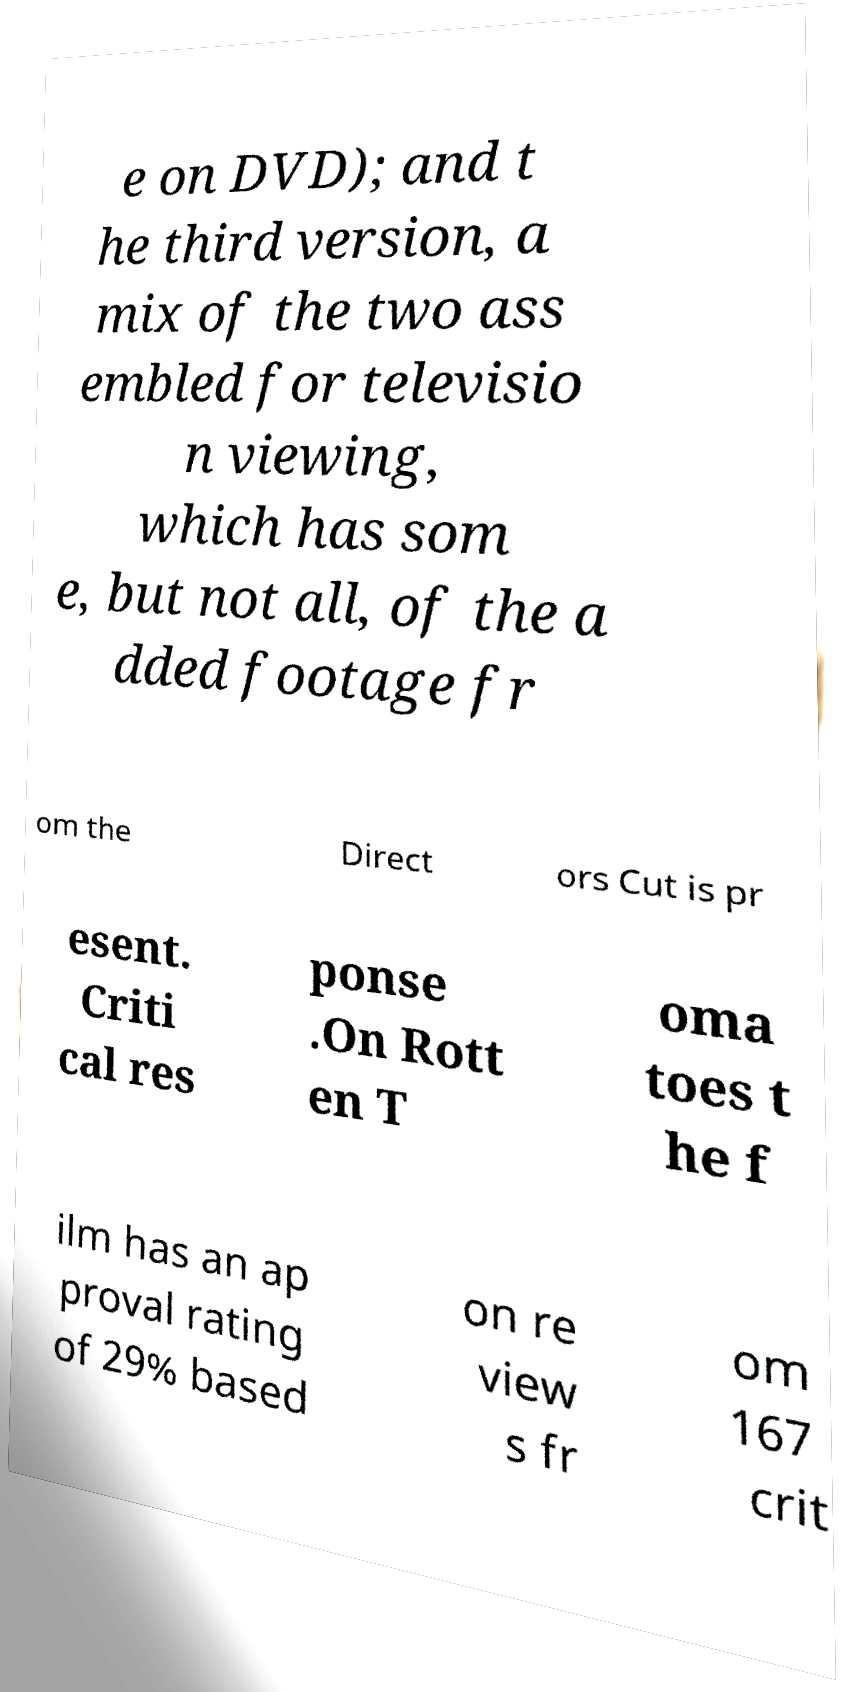I need the written content from this picture converted into text. Can you do that? e on DVD); and t he third version, a mix of the two ass embled for televisio n viewing, which has som e, but not all, of the a dded footage fr om the Direct ors Cut is pr esent. Criti cal res ponse .On Rott en T oma toes t he f ilm has an ap proval rating of 29% based on re view s fr om 167 crit 